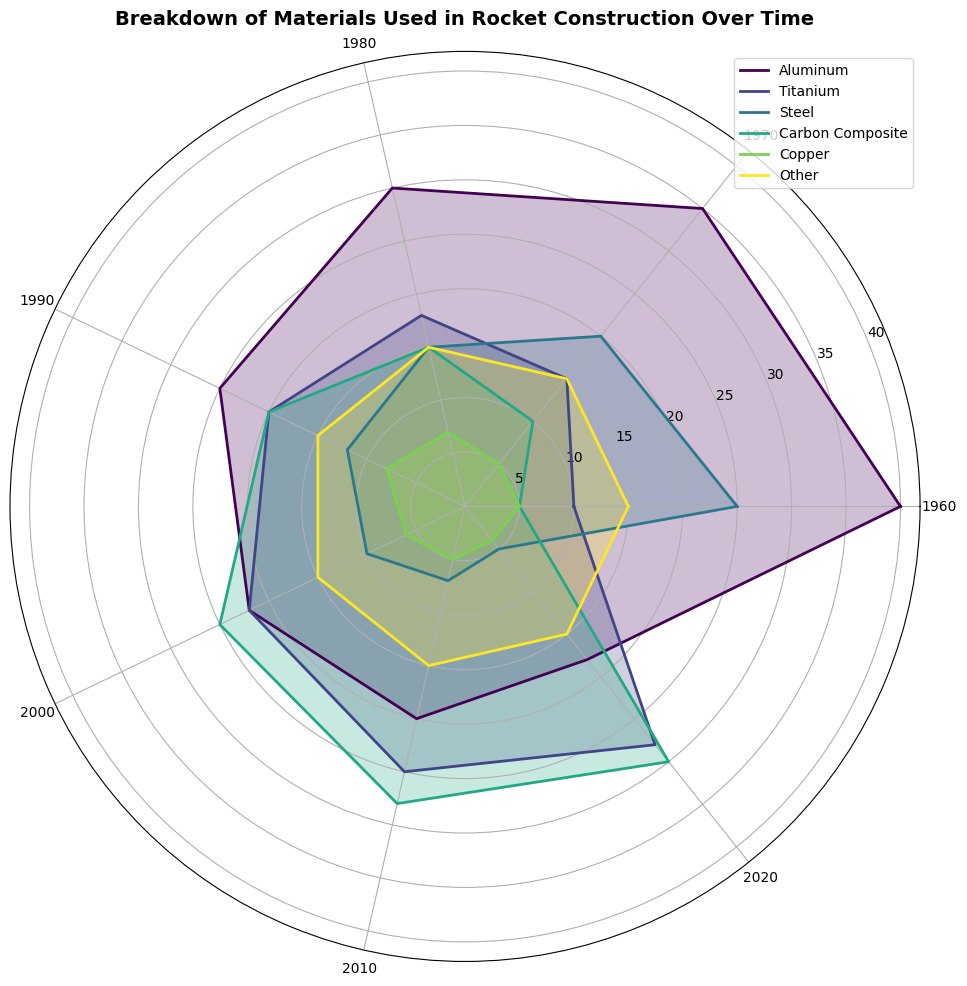What material showed the most consistent percentage over time? The percentage of the "Other" materials remained constant at 15% across all the years.
Answer: Other In which year did Carbon Composite see the highest percentage in rocket construction? By observing the radial lines, the highest value for Carbon Composite is found in 2020, where the percentage reaches 30%.
Answer: 2020 Which material's usage decreased the most from 1960 to 2020? By comparing the percentage values for each material in 1960 and 2020, Aluminum decreased from 40% to 18%, showing the largest drop.
Answer: Aluminum How did the usage of Titanium change from 1990 to 2010? In 1990, the percentage of Titanium was 20% and it increased to 25% in 2010.
Answer: Increased What is the average percentage of Steel used in rocket construction over the decades? Calculate the average by adding the percentages of Steel across all years and dividing by the number of years: (25 + 20 + 15 + 12 + 10 + 7 + 5) / 7 = 13.43
Answer: 13.43 Which two materials interchange their dominance in 2000 and 2010? In 2000, Carbon Composite had a higher percentage (25%) than Titanium (22%), but in 2010, Titanium (25%) overtook Carbon Composite (28%).
Answer: Titanium and Carbon Composite What is the percentage difference of Aluminum between 1980 and 2000? Subtract the Aluminum percentage in 2000 (22%) from that in 1980 (30%), which results in an 8% difference.
Answer: 8 Which material had the highest usage percentage in 1970? By inspecting the figure, Aluminum had the highest usage at 35% in 1970.
Answer: Aluminum From the graph, which material showed the greatest increase in usage from 1960 to 2020? Carbon Composite increased from 5% in 1960 to 30% in 2020, which is a 25% increase, the greatest among all materials.
Answer: Carbon Composite What is the trend in the usage of Steel over the years? The percentage of Steel consistently decreases from 25% in 1960 to 5% in 2020.
Answer: Decreasing 